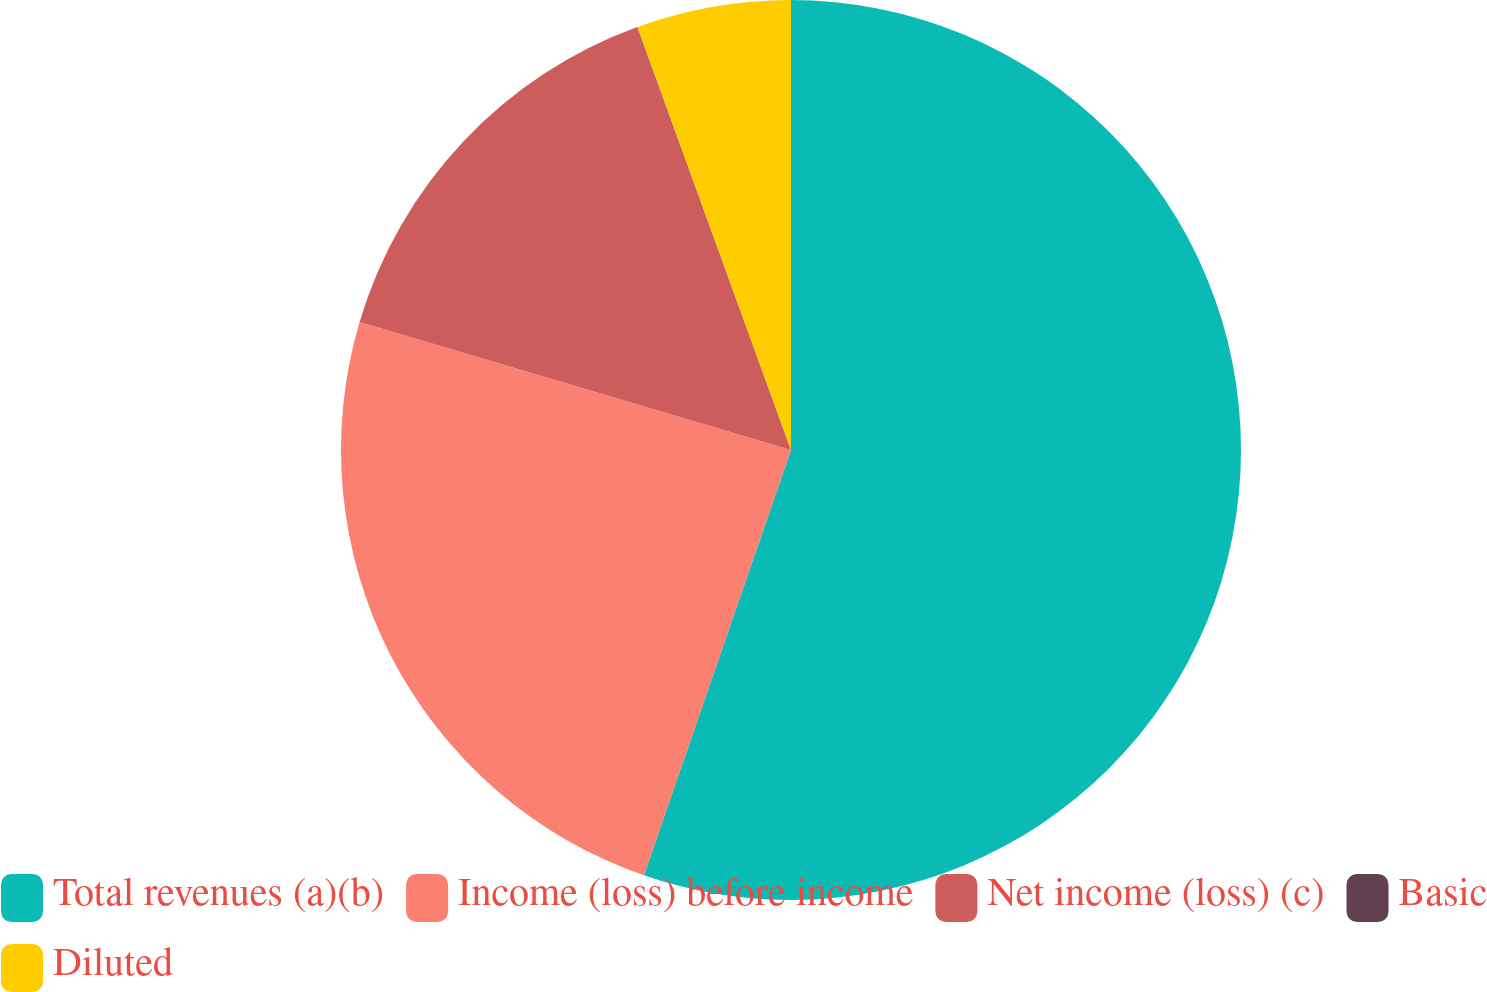Convert chart. <chart><loc_0><loc_0><loc_500><loc_500><pie_chart><fcel>Total revenues (a)(b)<fcel>Income (loss) before income<fcel>Net income (loss) (c)<fcel>Basic<fcel>Diluted<nl><fcel>55.3%<fcel>24.29%<fcel>14.86%<fcel>0.01%<fcel>5.54%<nl></chart> 